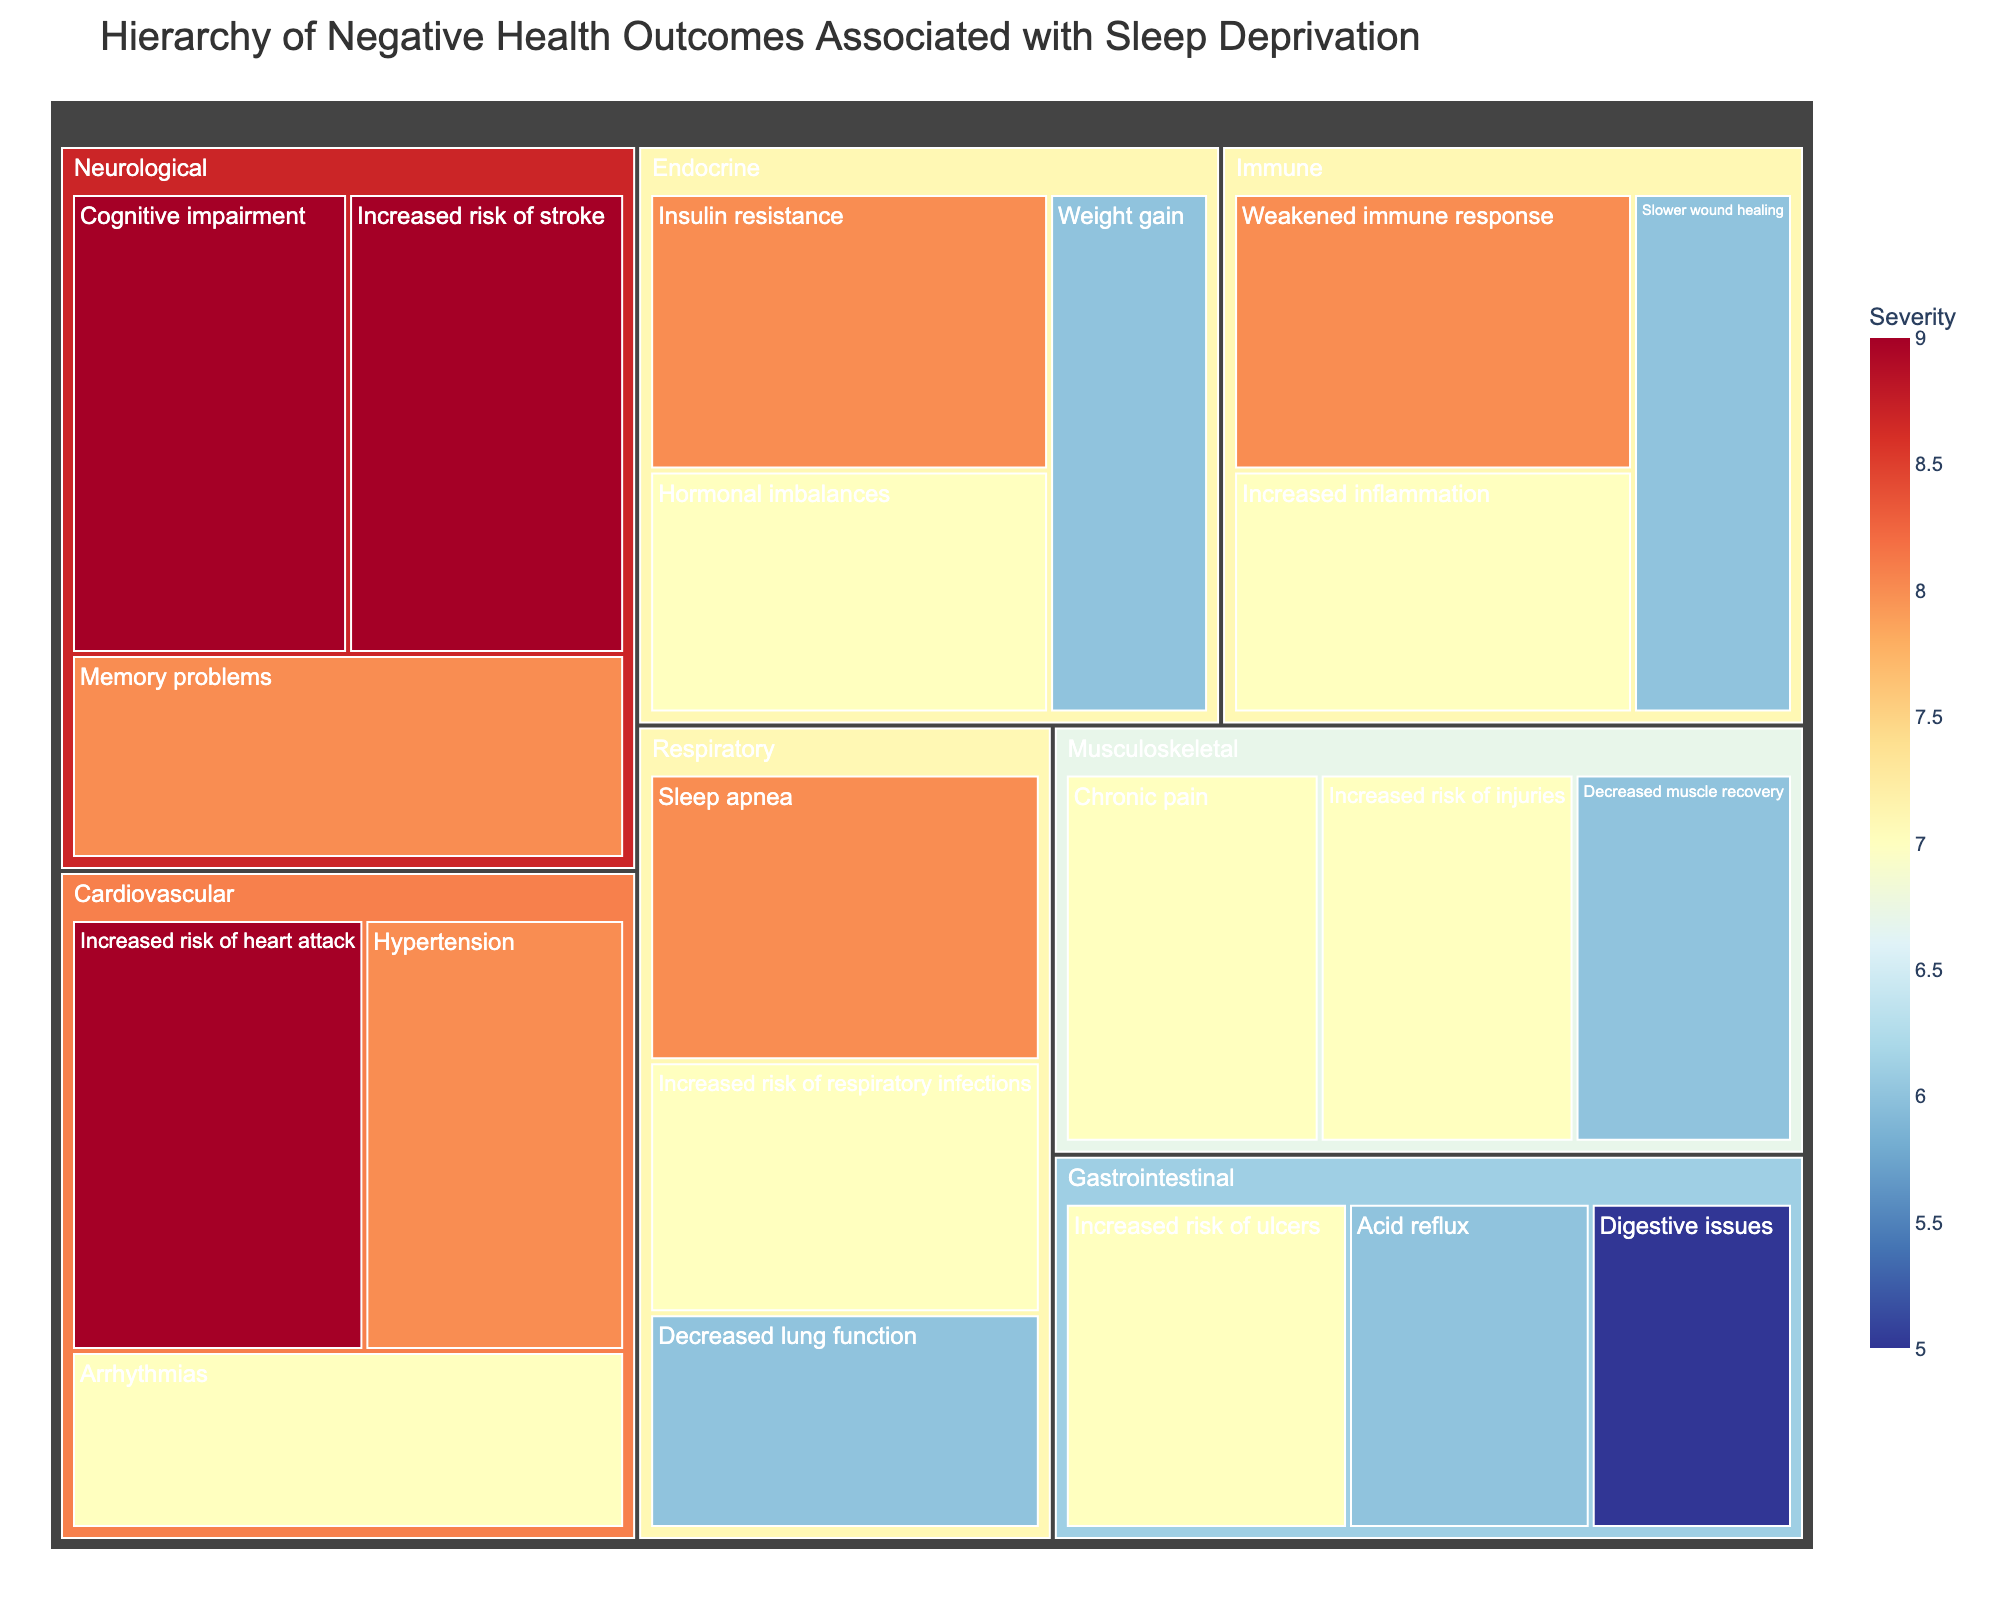What is the title of the figure? The title of the figure is usually displayed prominently at the top. In this case, it would be included as part of the render based on the provided code.
Answer: Hierarchy of Negative Health Outcomes Associated with Sleep Deprivation Which body system has the highest severity outcome listed? To determine this, we need to visually inspect which body system contains the outcome with the highest severity value mentioned.
Answer: Neurological and Cardiovascular What are the three outcomes with the highest severity? Look for the outcomes in the treemap with the highest severity values.
Answer: Increased risk of heart attack, Cognitive impairment, Increased risk of stroke Is there any outcome with the same severity across different systems? This requires scanning the treemap to see if the same severity value appears in different body systems.
Answer: Yes, severity 8 appears in multiple systems Which body system has the most variety of negative health outcomes? Count the number of distinct outcomes listed under each body system within the treemap.
Answer: Respiratory Which system has the lowest cumulative severity value of its outcomes? To determine this, sum the severity values for all outcomes within each body system and compare the totals.
Answer: Gastrointestinal How many outcomes are associated with the Immune system, and what is their average severity? Count the number of outcomes listed under the Immune system and then calculate the average severity.
Answer: 3 outcomes, average severity is 7 Which outcome in the Endocrine system has the highest severity, and what is it? Identify the highest severity number listed for outcomes under the Endocrine system.
Answer: Insulin resistance with a severity of 8 Compare the severity of Sleep Apnea and Cognitive Impairment. Which is higher? Locate the severity values for Sleep Apnea and Cognitive Impairment and compare them directly.
Answer: Cognitive impairment is higher Are there any outcomes within the Musculoskeletal system with a severity less than 7? Scan the treemap for Musculoskeletal outcomes and check their severity values.
Answer: Yes, Decreased muscle recovery 